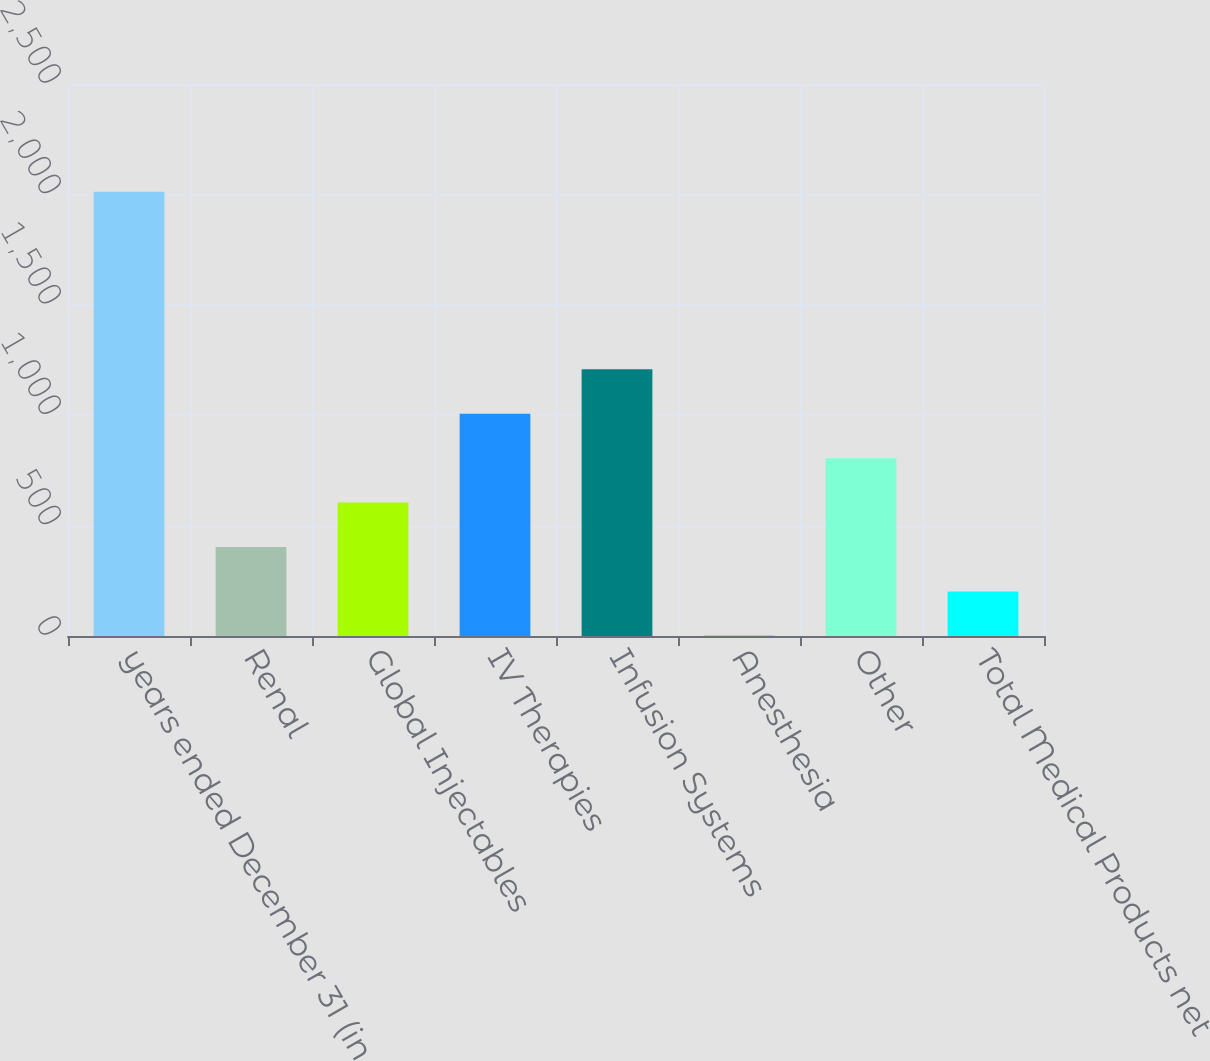<chart> <loc_0><loc_0><loc_500><loc_500><bar_chart><fcel>years ended December 31 (in<fcel>Renal<fcel>Global Injectables<fcel>IV Therapies<fcel>Infusion Systems<fcel>Anesthesia<fcel>Other<fcel>Total Medical Products net<nl><fcel>2012<fcel>403.2<fcel>604.3<fcel>1006.5<fcel>1207.6<fcel>1<fcel>805.4<fcel>202.1<nl></chart> 